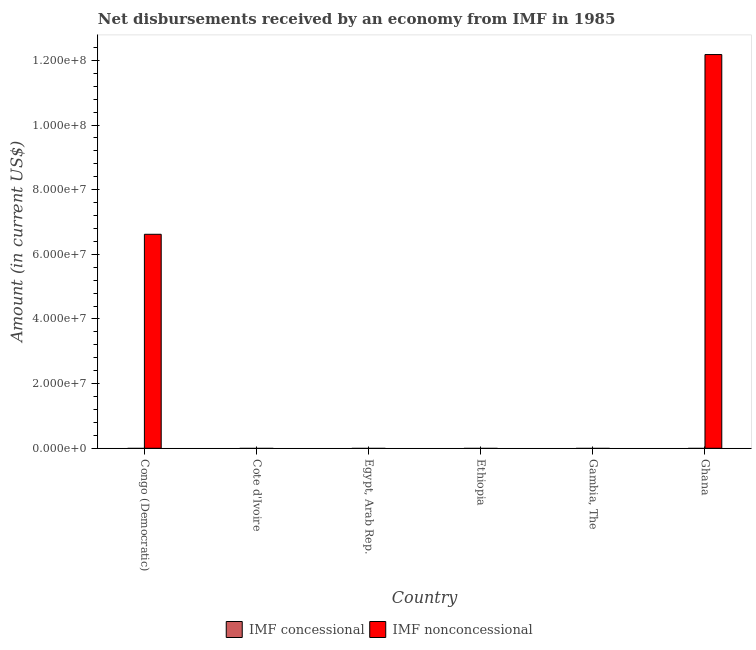How many different coloured bars are there?
Provide a succinct answer. 1. Are the number of bars on each tick of the X-axis equal?
Your response must be concise. No. How many bars are there on the 6th tick from the left?
Provide a succinct answer. 1. How many bars are there on the 3rd tick from the right?
Ensure brevity in your answer.  0. What is the label of the 1st group of bars from the left?
Ensure brevity in your answer.  Congo (Democratic). In how many cases, is the number of bars for a given country not equal to the number of legend labels?
Provide a succinct answer. 6. What is the net concessional disbursements from imf in Gambia, The?
Ensure brevity in your answer.  0. Across all countries, what is the maximum net non concessional disbursements from imf?
Make the answer very short. 1.22e+08. What is the ratio of the net non concessional disbursements from imf in Congo (Democratic) to that in Ghana?
Keep it short and to the point. 0.54. What is the difference between the highest and the lowest net non concessional disbursements from imf?
Provide a short and direct response. 1.22e+08. Are all the bars in the graph horizontal?
Provide a short and direct response. No. What is the difference between two consecutive major ticks on the Y-axis?
Provide a succinct answer. 2.00e+07. Are the values on the major ticks of Y-axis written in scientific E-notation?
Provide a succinct answer. Yes. Where does the legend appear in the graph?
Provide a short and direct response. Bottom center. How many legend labels are there?
Offer a terse response. 2. How are the legend labels stacked?
Your answer should be compact. Horizontal. What is the title of the graph?
Offer a terse response. Net disbursements received by an economy from IMF in 1985. Does "Electricity" appear as one of the legend labels in the graph?
Offer a terse response. No. What is the label or title of the X-axis?
Your response must be concise. Country. What is the label or title of the Y-axis?
Offer a terse response. Amount (in current US$). What is the Amount (in current US$) in IMF concessional in Congo (Democratic)?
Provide a short and direct response. 0. What is the Amount (in current US$) in IMF nonconcessional in Congo (Democratic)?
Provide a succinct answer. 6.62e+07. What is the Amount (in current US$) in IMF concessional in Cote d'Ivoire?
Make the answer very short. 0. What is the Amount (in current US$) of IMF nonconcessional in Cote d'Ivoire?
Provide a short and direct response. 0. What is the Amount (in current US$) in IMF concessional in Ethiopia?
Offer a terse response. 0. What is the Amount (in current US$) in IMF nonconcessional in Ethiopia?
Offer a terse response. 0. What is the Amount (in current US$) in IMF nonconcessional in Ghana?
Provide a succinct answer. 1.22e+08. Across all countries, what is the maximum Amount (in current US$) in IMF nonconcessional?
Make the answer very short. 1.22e+08. What is the total Amount (in current US$) of IMF concessional in the graph?
Ensure brevity in your answer.  0. What is the total Amount (in current US$) of IMF nonconcessional in the graph?
Your response must be concise. 1.88e+08. What is the difference between the Amount (in current US$) of IMF nonconcessional in Congo (Democratic) and that in Ghana?
Offer a terse response. -5.56e+07. What is the average Amount (in current US$) of IMF nonconcessional per country?
Your response must be concise. 3.13e+07. What is the ratio of the Amount (in current US$) in IMF nonconcessional in Congo (Democratic) to that in Ghana?
Make the answer very short. 0.54. What is the difference between the highest and the lowest Amount (in current US$) in IMF nonconcessional?
Your answer should be compact. 1.22e+08. 